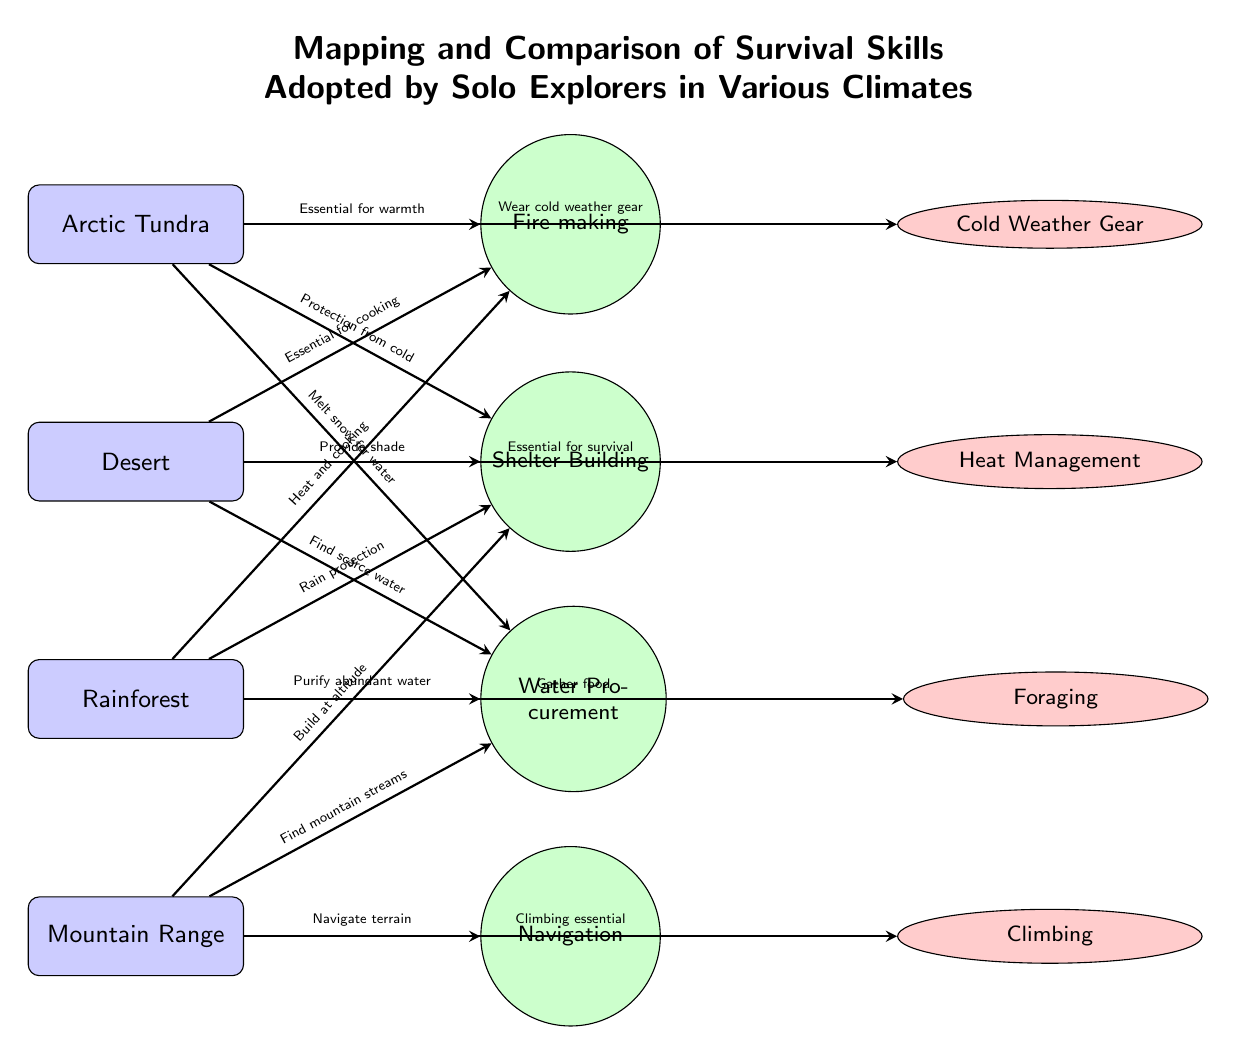What survival skill is essential for warmth in the Arctic Tundra? The diagram indicates that Fire-making is essential for warmth in the Arctic Tundra, as shown by the arrow connecting the region to the skill.
Answer: Fire-making Which strategy is linked to water procurement in the Desert? The strategy associated with water procurement in the Desert, according to the diagram, is Heat Management, as indicated by the arrow.
Answer: Heat Management How many regions are represented in the diagram? The diagram includes four regions: Arctic Tundra, Desert, Rainforest, and Mountain Range, established by counting the region nodes.
Answer: 4 What skill is required for cooking in the Rainforest? Fire-making is the skill linked to the need for heat and cooking in the Rainforest, shown by the direct connection in the diagram.
Answer: Fire-making Which region requires climbing as part of survival strategy? The Mountain Range is the region that necessitates climbing as a survival strategy, indicated by the connection from Mountain to Climbing in the diagram.
Answer: Mountain Range What is the relationship between the Desert and the skill of Shelter Building? The diagram illustrates that in the Desert, Shelter Building is directly connected with providing shade, highlighting its importance in that region.
Answer: Provide shade What strategy is crucial in the Rainforest for food procurement? The diagram shows that Foraging is the strategy essential for gathering food in the Rainforest, as indicated by the direct arrow linking them.
Answer: Foraging Which skill correlates with navigation in the Mountain Range? The skill associated with navigation in the Mountain Range is Navigation itself, as indicated by the direct relationship illustrated in the diagram.
Answer: Navigation 